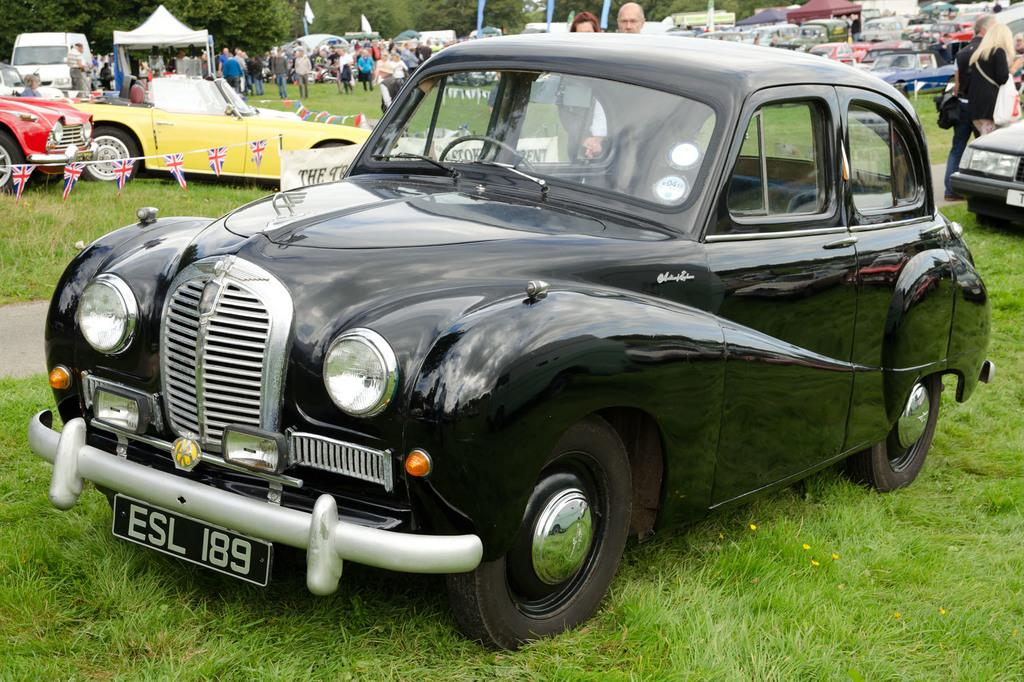What is located on the grass in the image? There are vehicles on the grass in the image. What can be seen in the image besides the vehicles? There is a group of people standing and stalls in the image. What type of decorations are present in the image? Decorative flags are present in the image. What is visible in the background of the image? There are trees in the background of the image. Can you tell me who won the argument between the bone and the route in the image? There is no argument, bone, or route present in the image. The image features vehicles, people, stalls, decorative flags, and trees. 